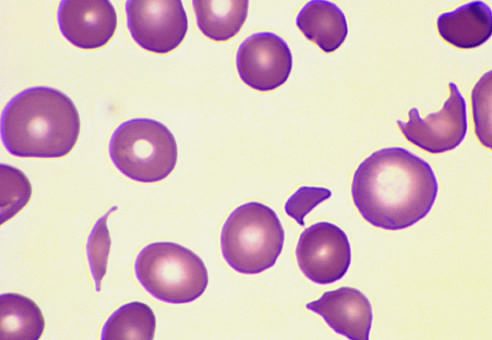what does this specimen from a patient with hemolytic uremic syndrome contain?
Answer the question using a single word or phrase. Several fragmented red cells 